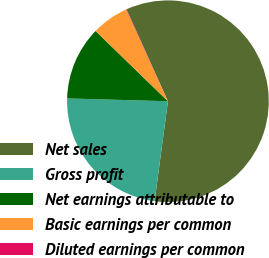<chart> <loc_0><loc_0><loc_500><loc_500><pie_chart><fcel>Net sales<fcel>Gross profit<fcel>Net earnings attributable to<fcel>Basic earnings per common<fcel>Diluted earnings per common<nl><fcel>58.84%<fcel>23.34%<fcel>11.82%<fcel>5.94%<fcel>0.06%<nl></chart> 